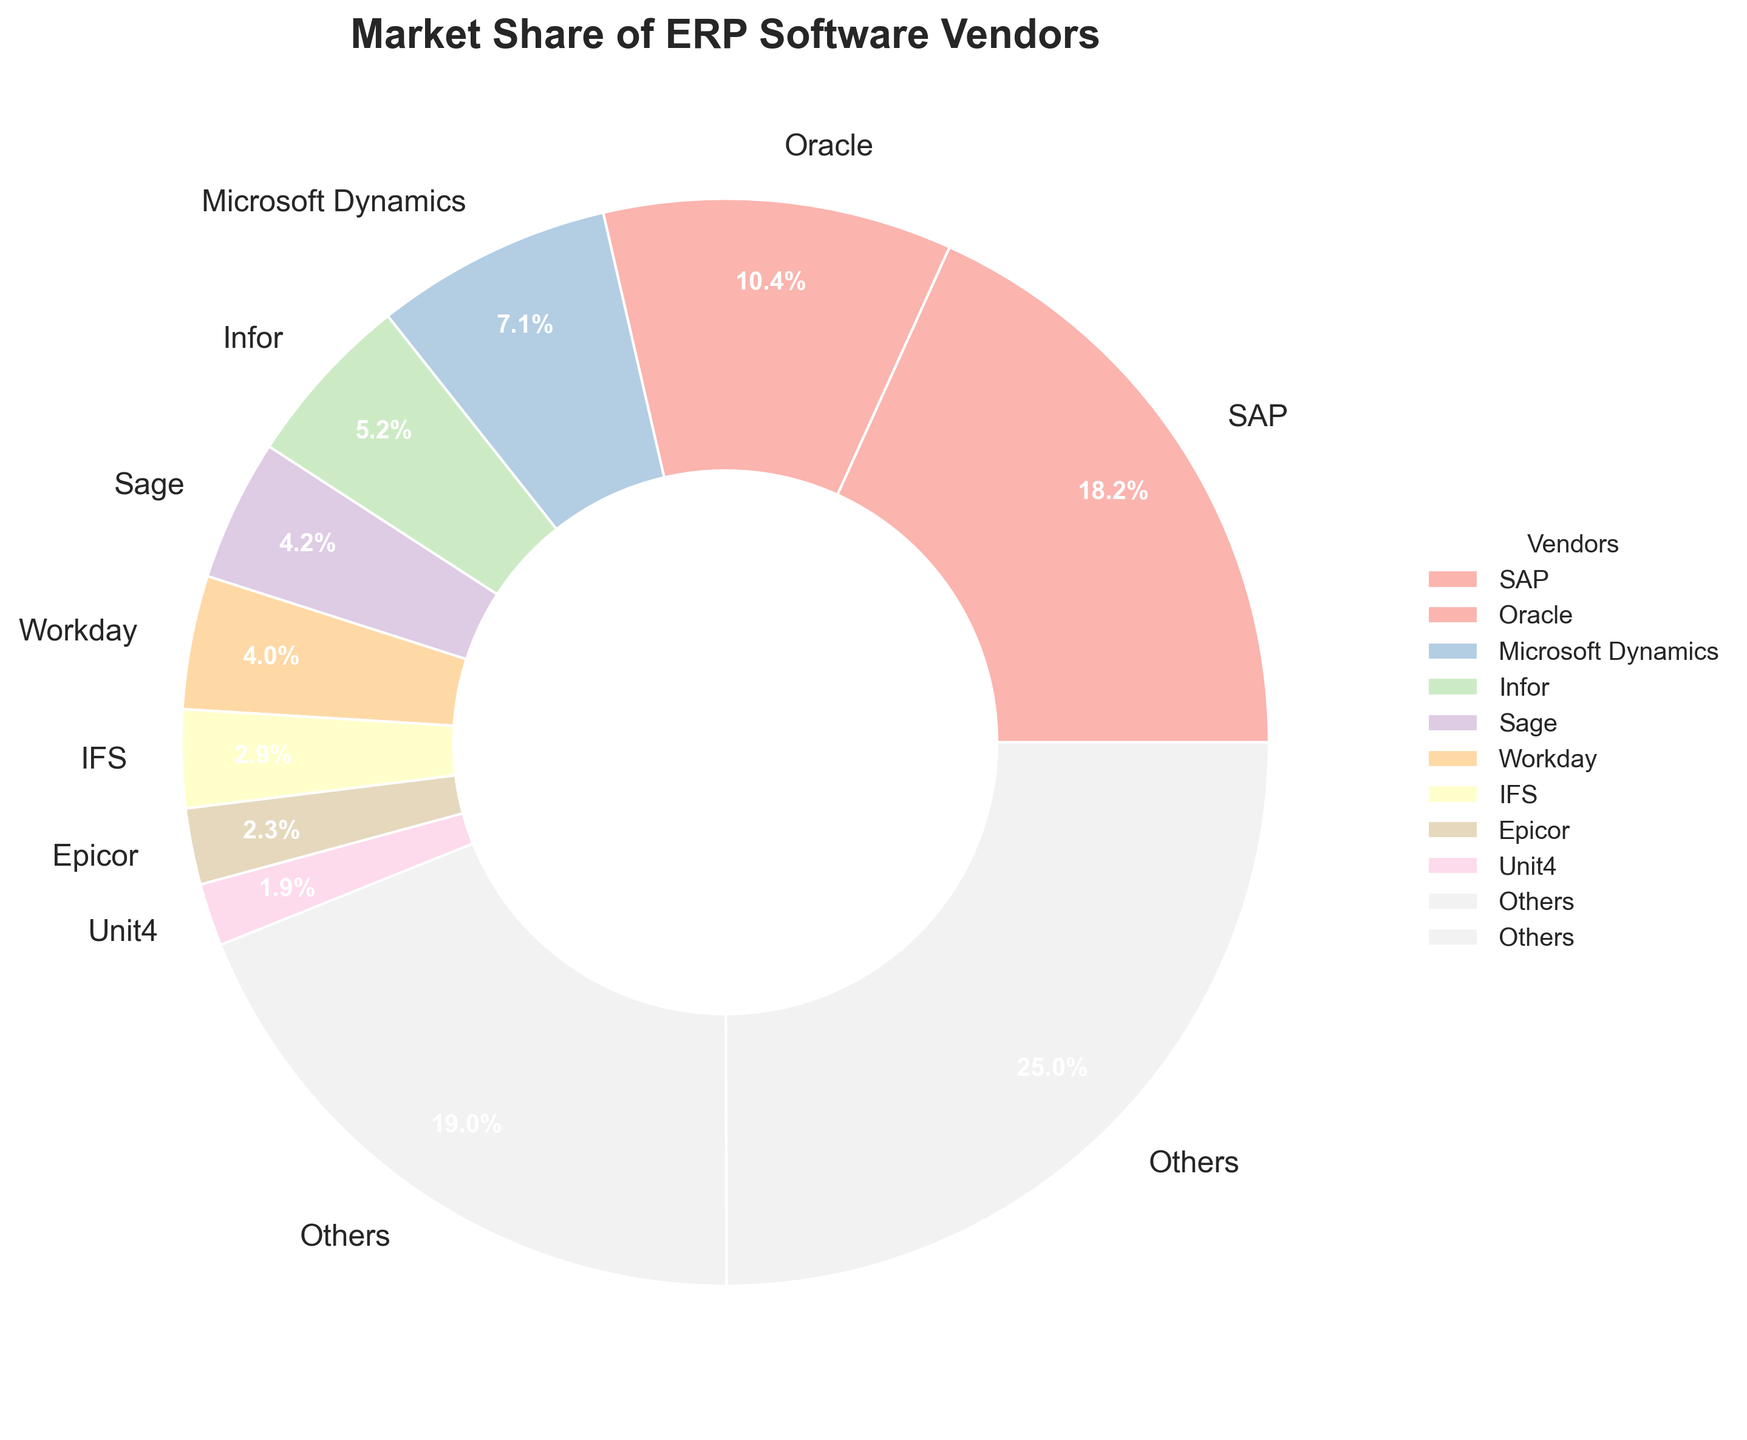What's the market share percentage of SAP? SAP occupies the largest section of the pie chart with a label indicating its market share percentage.
Answer: 22.5% What's the combined market share of Oracle and Microsoft Dynamics? The pie chart shows Oracle's market share at 12.8% and Microsoft Dynamics' at 8.7%. Adding these together gives 12.8 + 8.7 = 21.5%.
Answer: 21.5% Which vendor has the smallest market share greater than 2% but less than 5%? In the pie chart, any vendor with market share greater than 2% but less than 5% includes Infor (6.4%), Sage (5.2%), and Workday (4.9%). Workday falls in the range.
Answer: Workday How does the market share of Infor compare to Sage? The pie chart shows that Infor has a market share of 6.4% and Sage has 5.2%. Infor's market share is greater than Sage's.
Answer: Infor is greater What is the total market share represented by the 'Others' category in the pie chart? The pie chart aggregates shares of smaller vendors into 'Others'. The total market share of 'Others' is indicated on the pie chart section.
Answer: 23.4% How many vendors have a market share above 10%? In the pie chart, only SAP (22.5%) and Oracle (12.8%) have market shares above 10%.
Answer: 2 Which color is used to represent SAP in the pie chart? The section of the pie chart corresponding to SAP is colored, and upon inspection, we identify the specific color used for it. This may require viewing the actual chart.
Answer: (Answer based on chart color) Between Epicor and Unit4, which vendor has a larger market share and by how much? According to the pie chart, Epicor has a market share of 2.8% and Unit4 has 2.3%. The difference is calculated by 2.8 - 2.3 = 0.5%.
Answer: Epicor by 0.5% What's the market share for the three smallest vendors listed individually on the pie chart combined (excluding 'Others')? Identifying the three smallest individual vendors from the pie chart (Acumatica 1.2%, Deltek 1.1%, and IQMS 1.5%) and adding their shares together: 1.2 + 1.1 + 1.5 = 3.8%.
Answer: 3.8% 